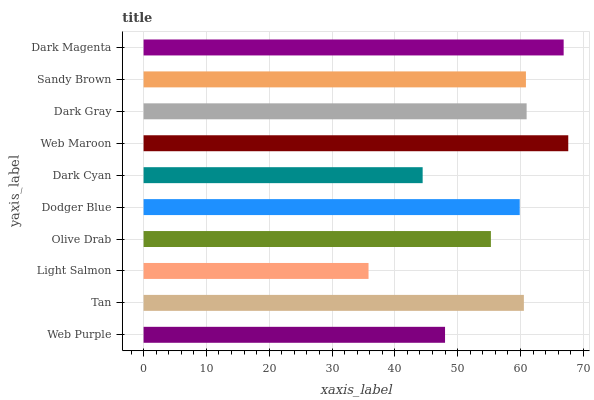Is Light Salmon the minimum?
Answer yes or no. Yes. Is Web Maroon the maximum?
Answer yes or no. Yes. Is Tan the minimum?
Answer yes or no. No. Is Tan the maximum?
Answer yes or no. No. Is Tan greater than Web Purple?
Answer yes or no. Yes. Is Web Purple less than Tan?
Answer yes or no. Yes. Is Web Purple greater than Tan?
Answer yes or no. No. Is Tan less than Web Purple?
Answer yes or no. No. Is Tan the high median?
Answer yes or no. Yes. Is Dodger Blue the low median?
Answer yes or no. Yes. Is Light Salmon the high median?
Answer yes or no. No. Is Sandy Brown the low median?
Answer yes or no. No. 